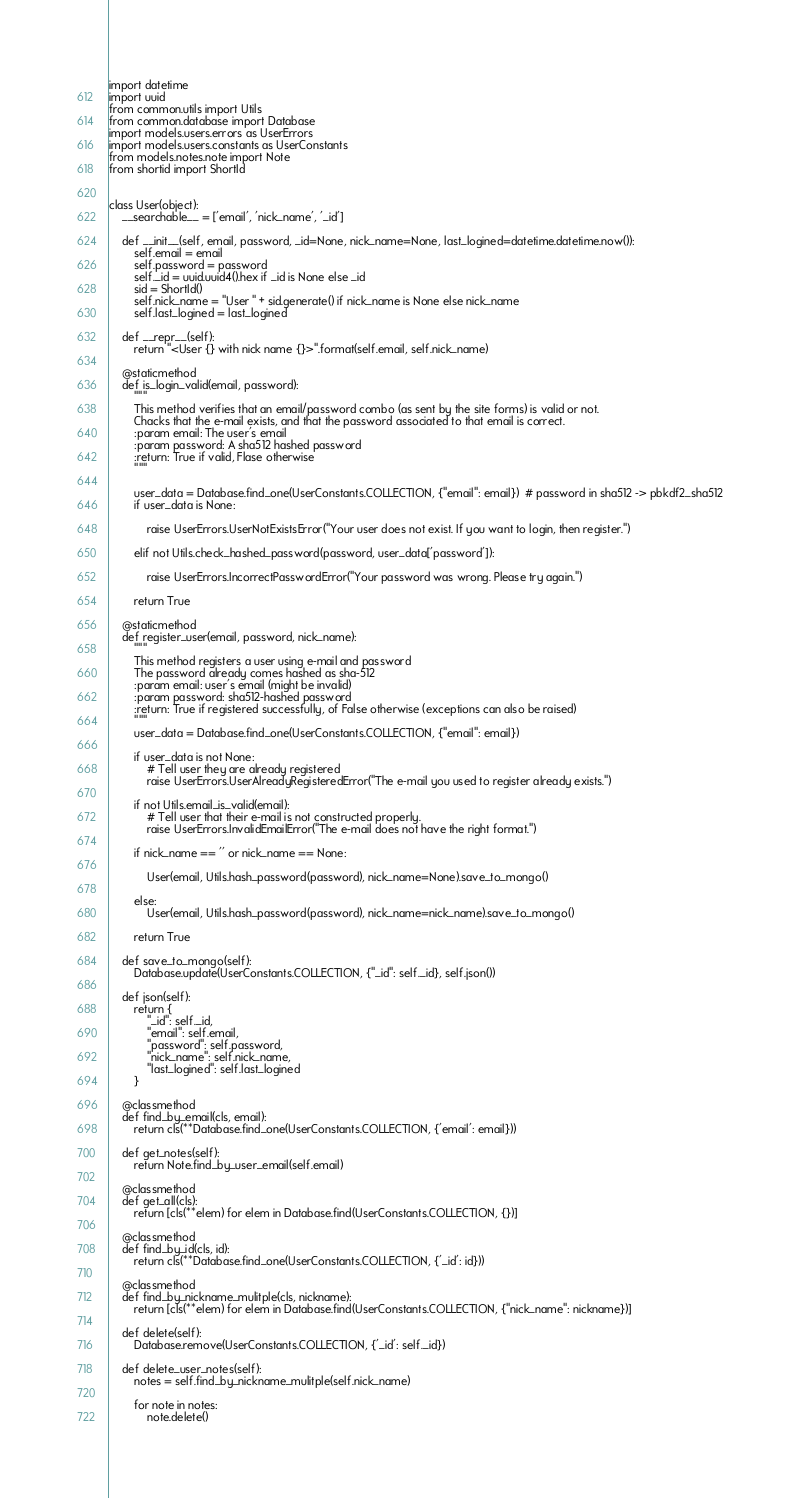Convert code to text. <code><loc_0><loc_0><loc_500><loc_500><_Python_>import datetime
import uuid
from common.utils import Utils
from common.database import Database
import models.users.errors as UserErrors
import models.users.constants as UserConstants
from models.notes.note import Note
from shortid import ShortId


class User(object):
    __searchable__ = ['email', 'nick_name', '_id']

    def __init__(self, email, password, _id=None, nick_name=None, last_logined=datetime.datetime.now()):
        self.email = email
        self.password = password
        self._id = uuid.uuid4().hex if _id is None else _id
        sid = ShortId()
        self.nick_name = "User " + sid.generate() if nick_name is None else nick_name
        self.last_logined = last_logined

    def __repr__(self):
        return "<User {} with nick name {}>".format(self.email, self.nick_name)

    @staticmethod
    def is_login_valid(email, password):
        """
        This method verifies that an email/password combo (as sent by the site forms) is valid or not.
        Chacks that the e-mail exists, and that the password associated to that email is correct.
        :param email: The user's email
        :param password: A sha512 hashed password
        :return: True if valid, Flase otherwise
        """

        user_data = Database.find_one(UserConstants.COLLECTION, {"email": email})  # password in sha512 -> pbkdf2_sha512
        if user_data is None:

            raise UserErrors.UserNotExistsError("Your user does not exist. If you want to login, then register.")

        elif not Utils.check_hashed_password(password, user_data['password']):

            raise UserErrors.IncorrectPasswordError("Your password was wrong. Please try again.")

        return True

    @staticmethod
    def register_user(email, password, nick_name):
        """
        This method registers a user using e-mail and password
        The password already comes hashed as sha-512
        :param email: user's email (might be invalid)
        :param password: sha512-hashed password
        :return: True if registered successfully, of False otherwise (exceptions can also be raised)
        """
        user_data = Database.find_one(UserConstants.COLLECTION, {"email": email})

        if user_data is not None:
            # Tell user they are already registered
            raise UserErrors.UserAlreadyRegisteredError("The e-mail you used to register already exists.")

        if not Utils.email_is_valid(email):
            # Tell user that their e-mail is not constructed properly.
            raise UserErrors.InvalidEmailError("The e-mail does not have the right format.")

        if nick_name == '' or nick_name == None:

            User(email, Utils.hash_password(password), nick_name=None).save_to_mongo()

        else:
            User(email, Utils.hash_password(password), nick_name=nick_name).save_to_mongo()

        return True

    def save_to_mongo(self):
        Database.update(UserConstants.COLLECTION, {"_id": self._id}, self.json())

    def json(self):
        return {
            "_id": self._id,
            "email": self.email,
            "password": self.password,
            "nick_name": self.nick_name,
            "last_logined": self.last_logined
        }

    @classmethod
    def find_by_email(cls, email):
        return cls(**Database.find_one(UserConstants.COLLECTION, {'email': email}))

    def get_notes(self):
        return Note.find_by_user_email(self.email)

    @classmethod
    def get_all(cls):
        return [cls(**elem) for elem in Database.find(UserConstants.COLLECTION, {})]

    @classmethod
    def find_by_id(cls, id):
        return cls(**Database.find_one(UserConstants.COLLECTION, {'_id': id}))

    @classmethod
    def find_by_nickname_mulitple(cls, nickname):
        return [cls(**elem) for elem in Database.find(UserConstants.COLLECTION, {"nick_name": nickname})]

    def delete(self):
        Database.remove(UserConstants.COLLECTION, {'_id': self._id})

    def delete_user_notes(self):
        notes = self.find_by_nickname_mulitple(self.nick_name)

        for note in notes:
            note.delete()
</code> 